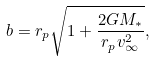Convert formula to latex. <formula><loc_0><loc_0><loc_500><loc_500>b = r _ { p } \sqrt { 1 + \frac { 2 G M _ { * } } { r _ { p } v _ { \infty } ^ { 2 } } } ,</formula> 